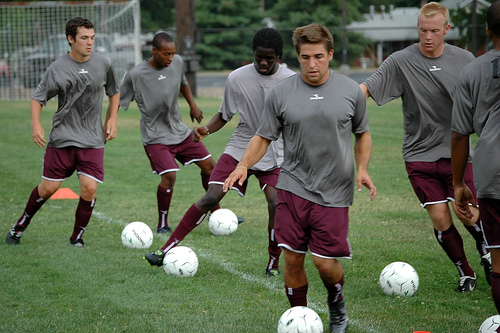<image>
Is the man on the ball? No. The man is not positioned on the ball. They may be near each other, but the man is not supported by or resting on top of the ball. Is there a ball next to the person? Yes. The ball is positioned adjacent to the person, located nearby in the same general area. Where is the ball in relation to the boy? Is it in front of the boy? No. The ball is not in front of the boy. The spatial positioning shows a different relationship between these objects. 